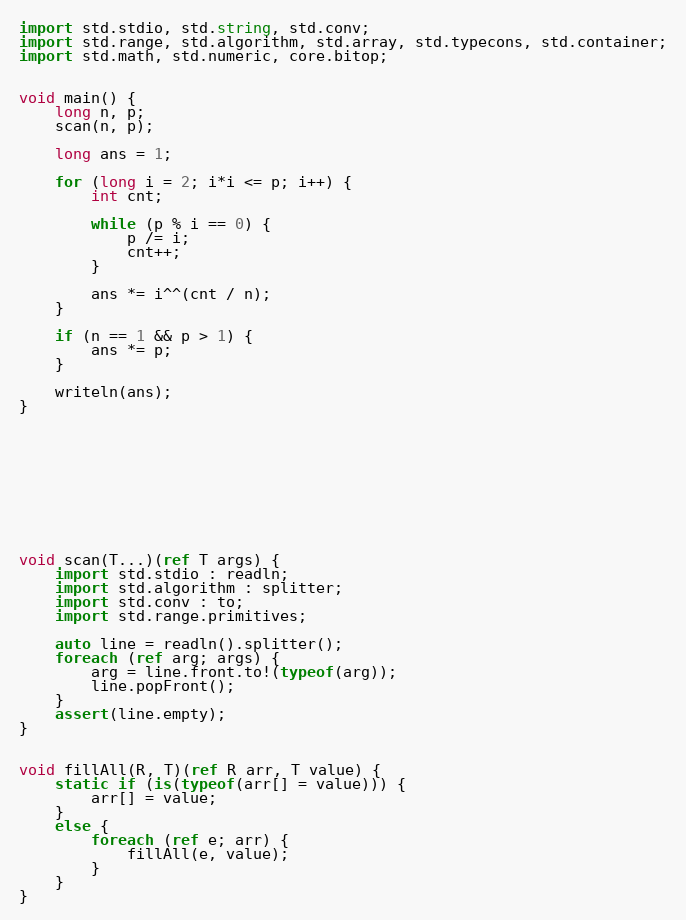Convert code to text. <code><loc_0><loc_0><loc_500><loc_500><_D_>import std.stdio, std.string, std.conv;
import std.range, std.algorithm, std.array, std.typecons, std.container;
import std.math, std.numeric, core.bitop;


void main() {
    long n, p;
    scan(n, p);

    long ans = 1;

    for (long i = 2; i*i <= p; i++) {
        int cnt;

        while (p % i == 0) {
            p /= i;
            cnt++;
        }

        ans *= i^^(cnt / n);
    }

    if (n == 1 && p > 1) {
        ans *= p;
    }

    writeln(ans);
}










void scan(T...)(ref T args) {
    import std.stdio : readln;
    import std.algorithm : splitter;
    import std.conv : to;
    import std.range.primitives;

    auto line = readln().splitter();
    foreach (ref arg; args) {
        arg = line.front.to!(typeof(arg));
        line.popFront();
    }
    assert(line.empty);
}


void fillAll(R, T)(ref R arr, T value) {
    static if (is(typeof(arr[] = value))) {
        arr[] = value;
    }
    else {
        foreach (ref e; arr) {
            fillAll(e, value);
        }
    }
}</code> 